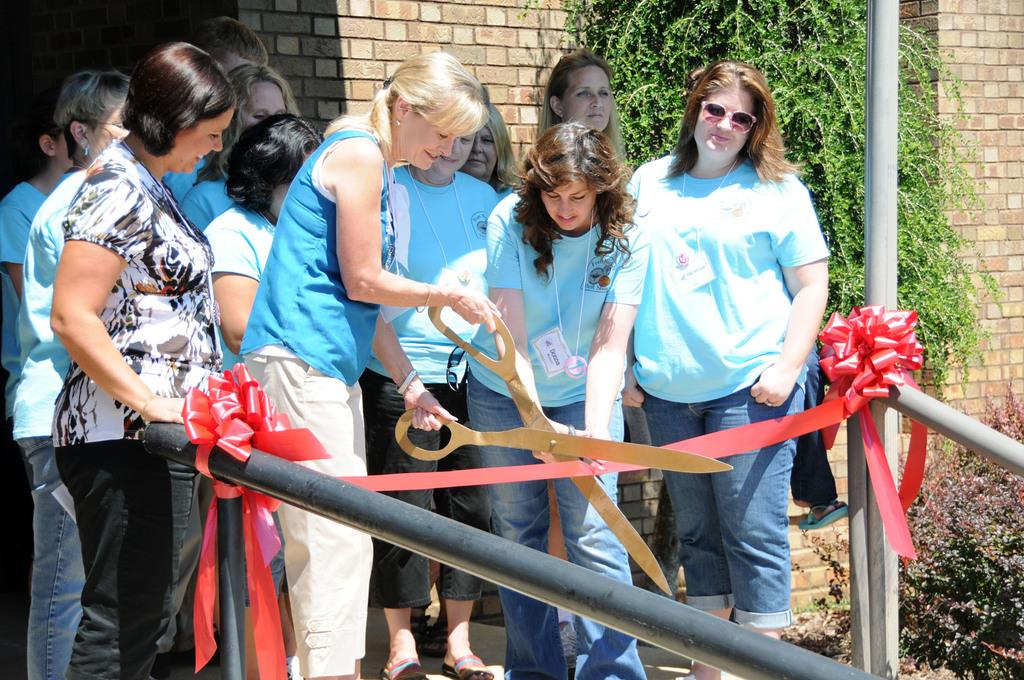What can be seen in the image involving people? There are people standing in the image. What object is present in the image that is typically used for cutting? There are scissors in the image. What is the purpose of the ribbon in the image? The ribbon is likely used for decoration or as a symbol of an event. What can be seen in the background of the image? There is a wall and a tree in the background of the image. What type of bird can be seen in the image? There is no bird present in the image. 